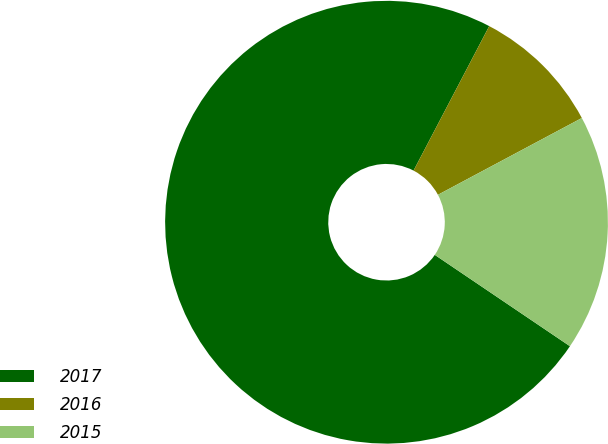Convert chart. <chart><loc_0><loc_0><loc_500><loc_500><pie_chart><fcel>2017<fcel>2016<fcel>2015<nl><fcel>73.21%<fcel>9.52%<fcel>17.26%<nl></chart> 